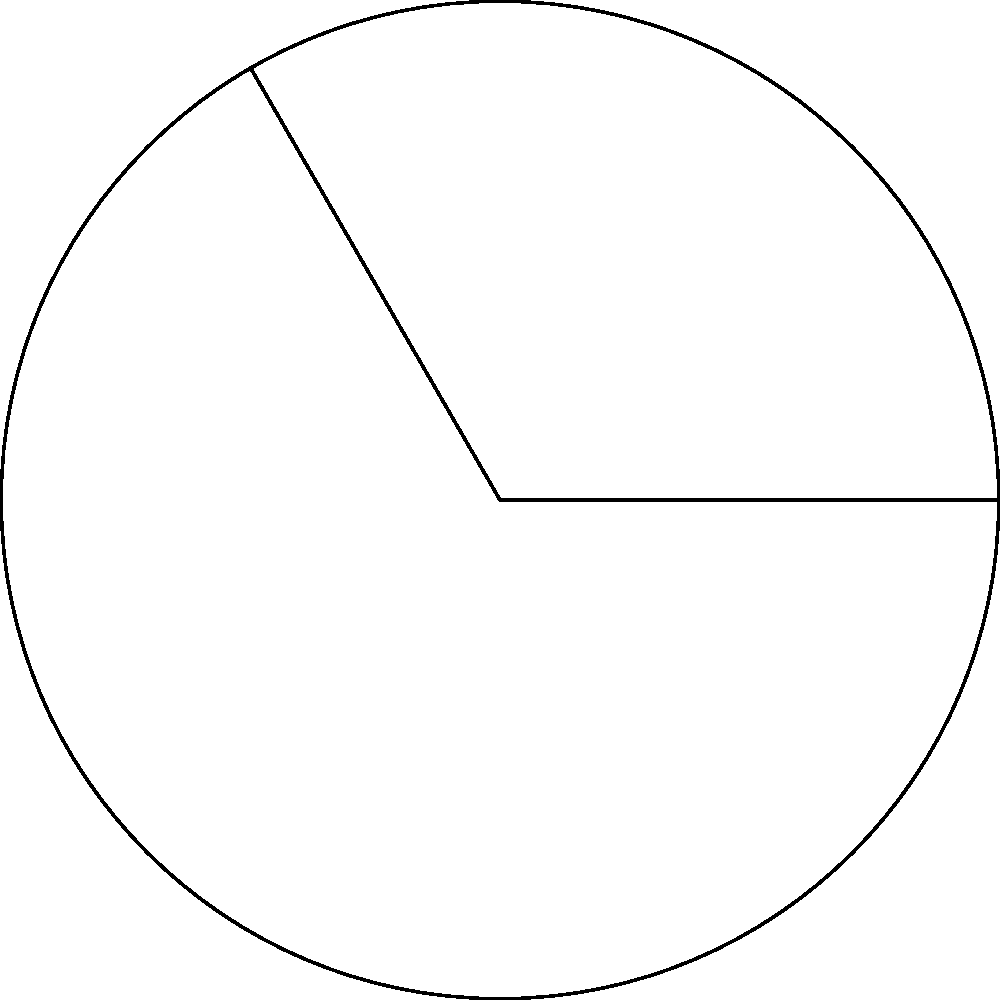In our library's circular reading room, we have a special curved bookshelf along the wall. The room has a radius of 6 meters, and the bookshelf spans a central angle of 120°. What is the length of this curved bookshelf? To find the length of the arc (curved bookshelf), we can use the formula for arc length:

$$\text{Arc Length} = \frac{\theta}{360°} \cdot 2\pi r$$

Where:
- $\theta$ is the central angle in degrees
- $r$ is the radius of the circle

Given:
- Radius ($r$) = 6 meters
- Central angle ($\theta$) = 120°

Step 1: Substitute the values into the formula
$$\text{Arc Length} = \frac{120°}{360°} \cdot 2\pi \cdot 6$$

Step 2: Simplify the fraction
$$\text{Arc Length} = \frac{1}{3} \cdot 2\pi \cdot 6$$

Step 3: Multiply
$$\text{Arc Length} = \frac{12\pi}{3} = 4\pi$$

Step 4: Calculate the final result (rounded to two decimal places)
$$\text{Arc Length} \approx 12.57 \text{ meters}$$

Therefore, the length of the curved bookshelf is approximately 12.57 meters.
Answer: $12.57 \text{ meters}$ 